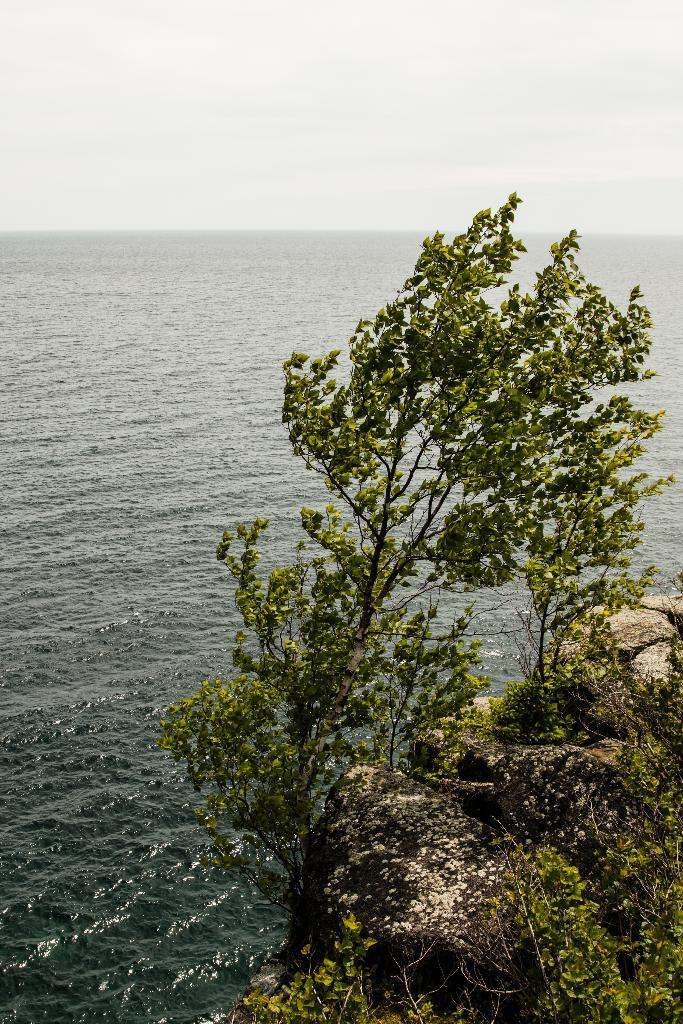What type of natural elements can be seen in the image? There are trees and rocks visible in the image. What else can be seen in the image besides trees and rocks? There is water visible in the image. What is visible in the background of the image? The sky is visible in the background of the image. Where is the hose located in the image? There is no hose present in the image. What type of food is being prepared with the rice in the image? There is no rice present in the image. 